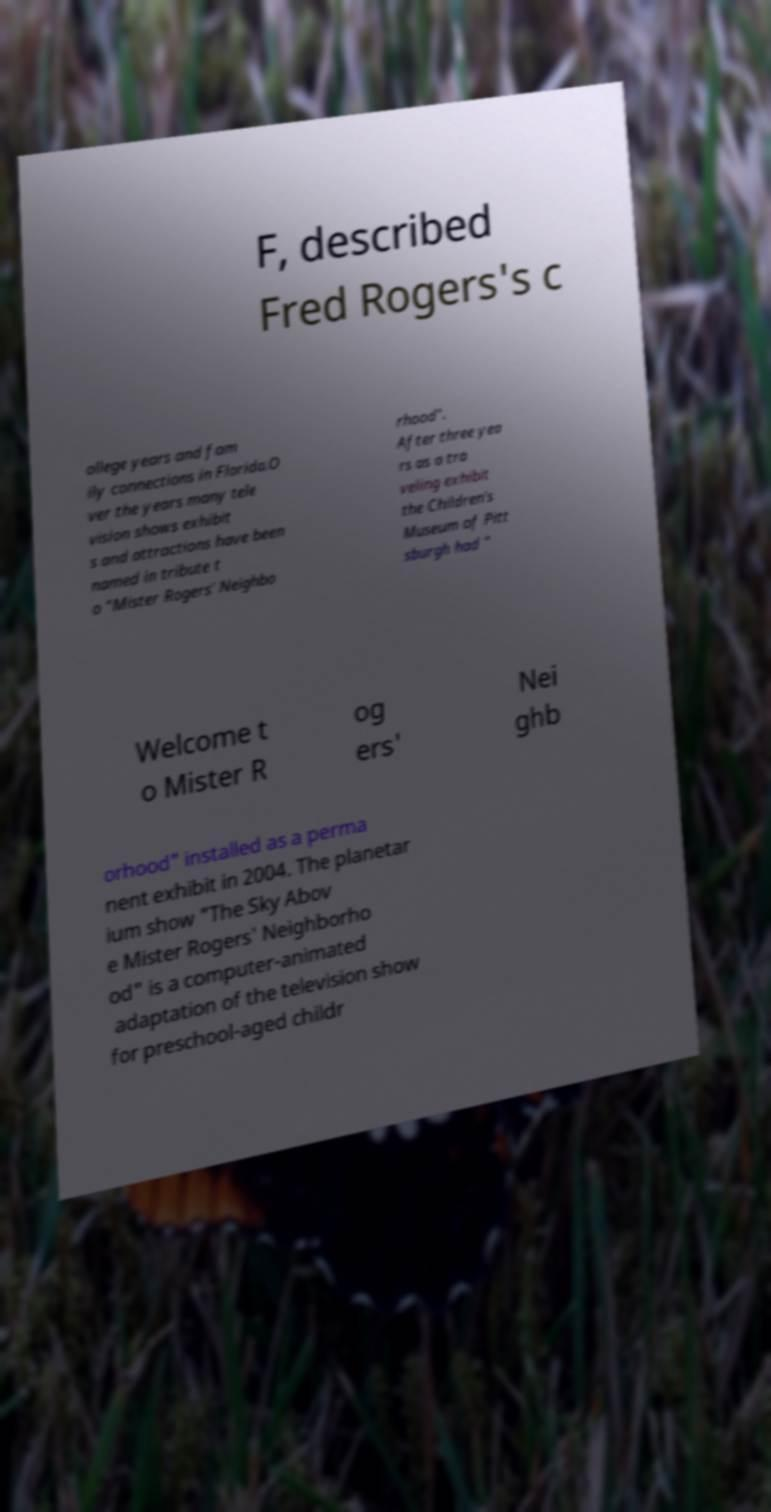For documentation purposes, I need the text within this image transcribed. Could you provide that? F, described Fred Rogers's c ollege years and fam ily connections in Florida.O ver the years many tele vision shows exhibit s and attractions have been named in tribute t o "Mister Rogers' Neighbo rhood". After three yea rs as a tra veling exhibit the Children's Museum of Pitt sburgh had " Welcome t o Mister R og ers' Nei ghb orhood" installed as a perma nent exhibit in 2004. The planetar ium show "The Sky Abov e Mister Rogers' Neighborho od" is a computer-animated adaptation of the television show for preschool-aged childr 